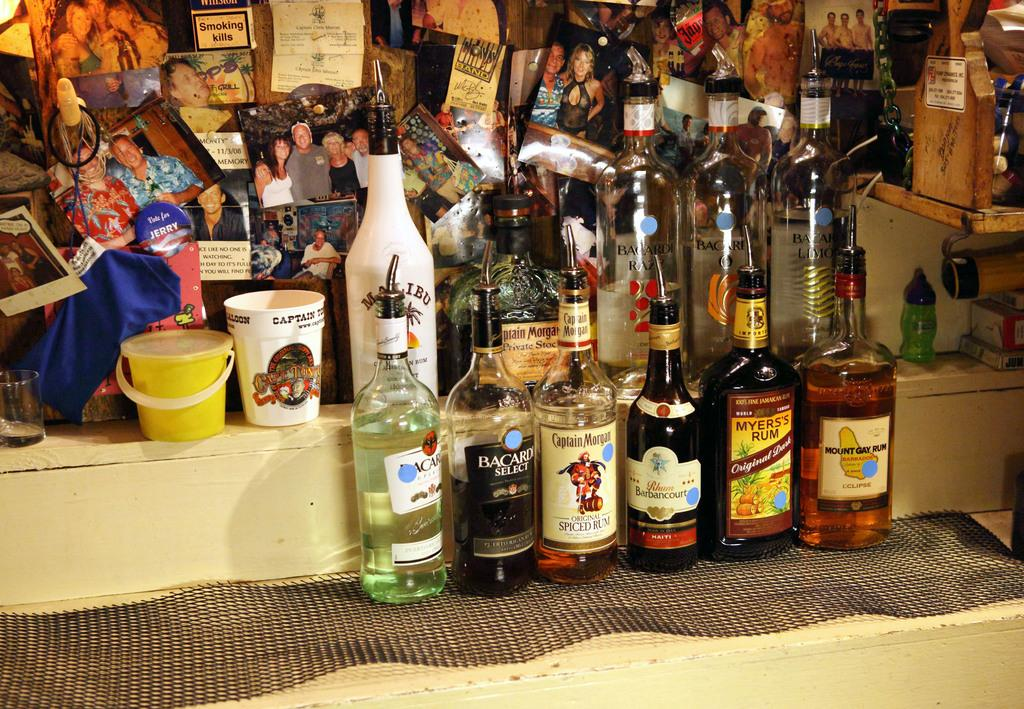<image>
Write a terse but informative summary of the picture. several bottles of liquor like Myers's Rum displayed together 